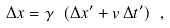<formula> <loc_0><loc_0><loc_500><loc_500>\Delta x = \gamma \ ( \Delta x ^ { \prime } + v \, \Delta t ^ { \prime } ) \ ,</formula> 